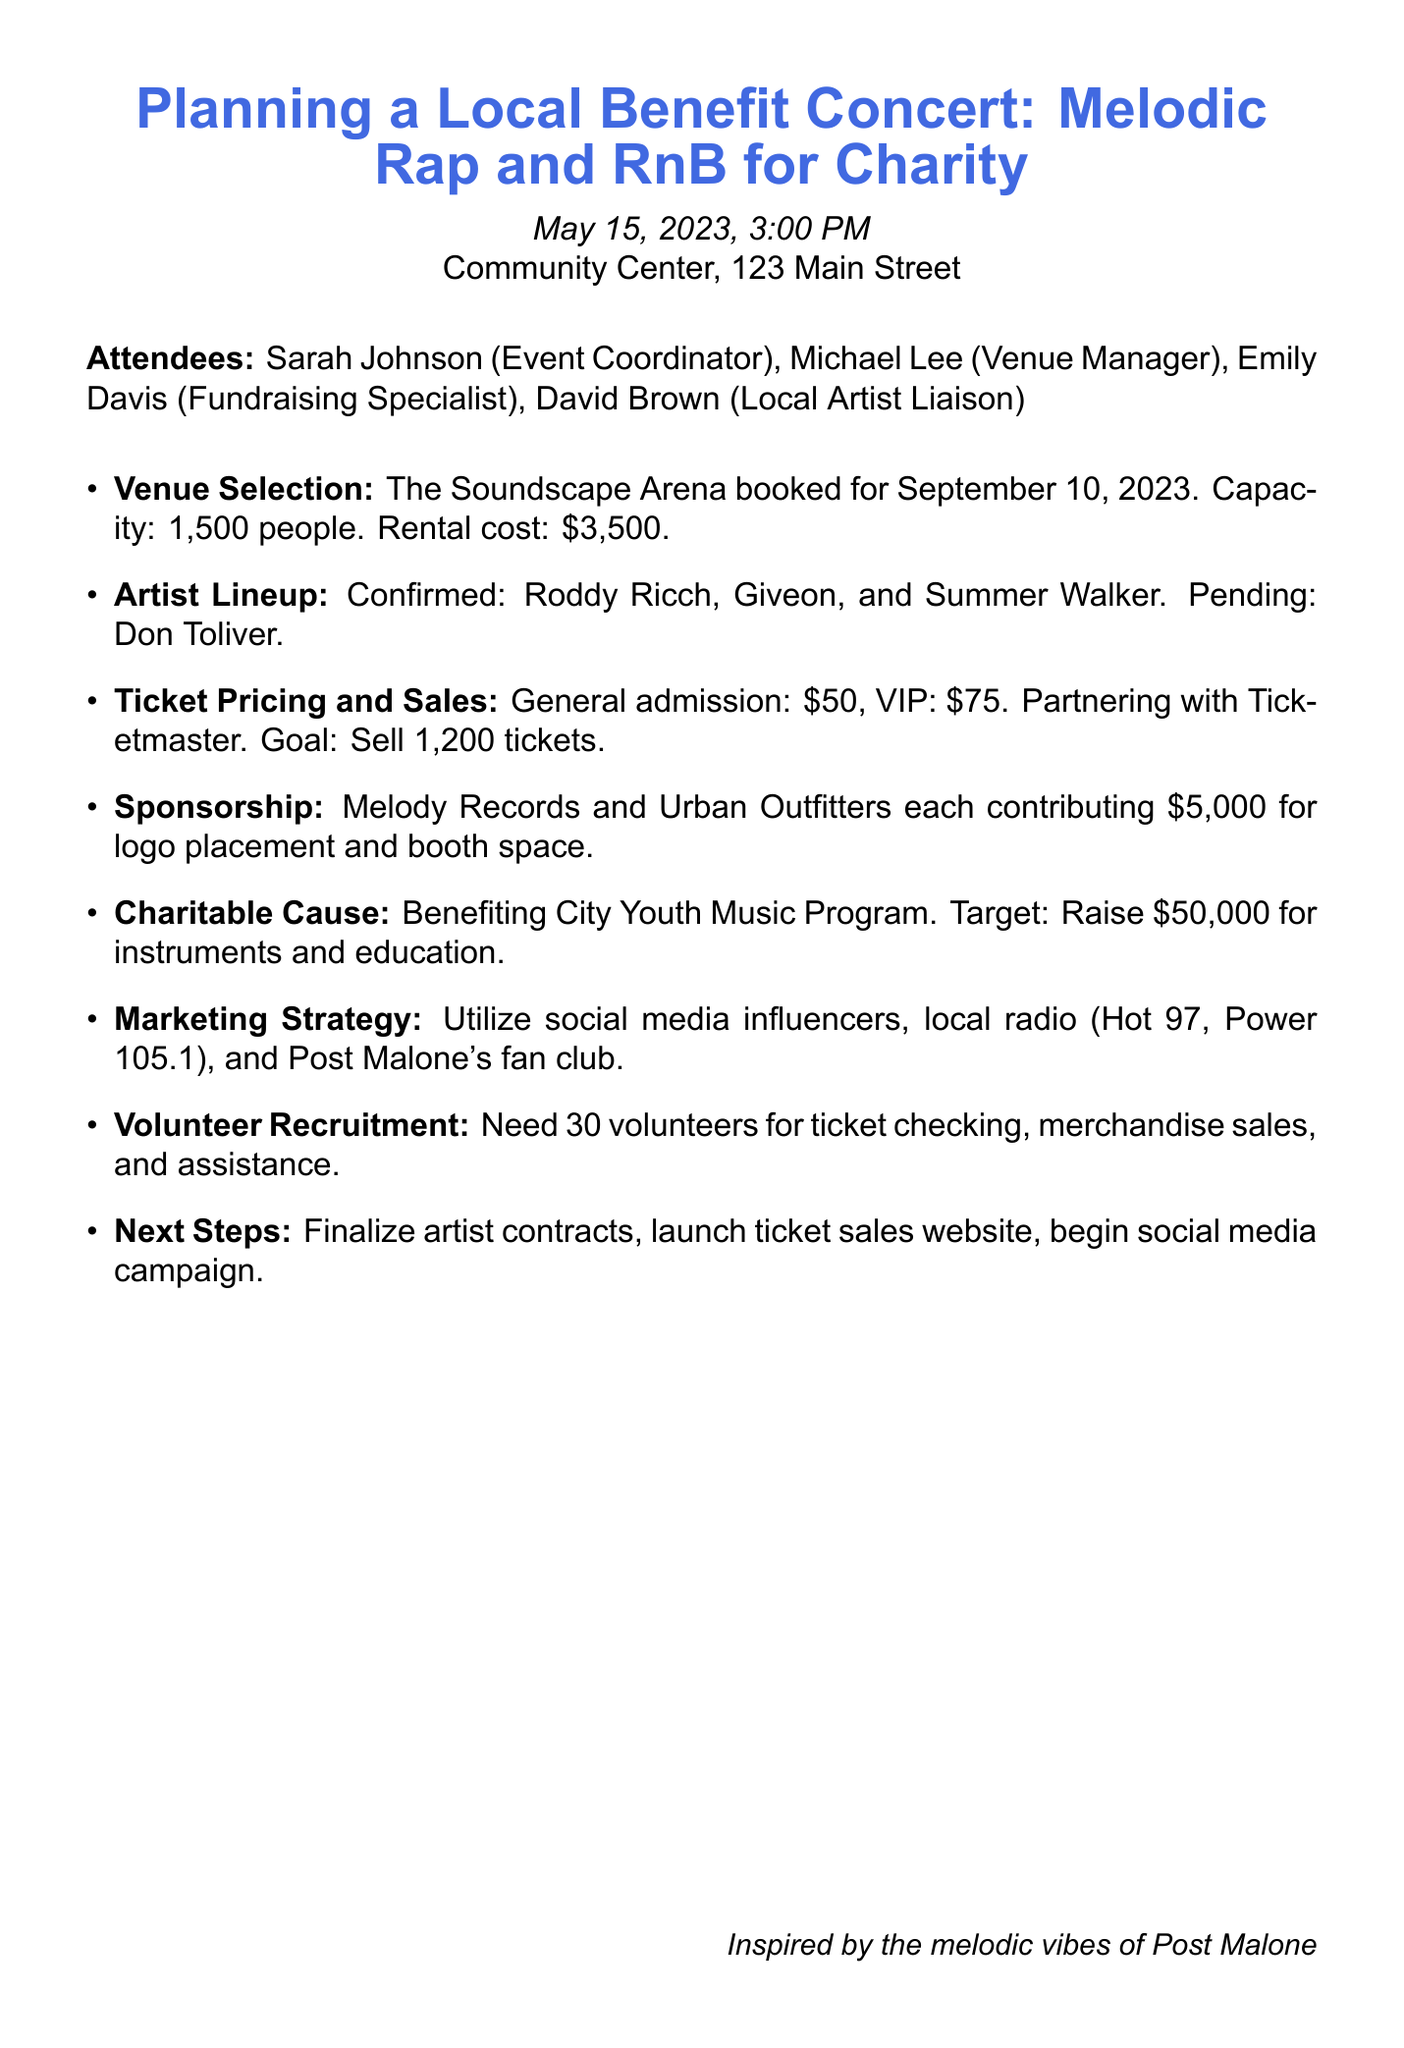What is the date of the concert? The concert is scheduled for September 10, 2023, as mentioned in the agenda under Venue Selection.
Answer: September 10, 2023 Who is the Event Coordinator? Sarah Johnson is listed as the Event Coordinator in the attendees section of the document.
Answer: Sarah Johnson What is the capacity of The Soundscape Arena? The capacity of The Soundscape Arena is mentioned to be 1,500 people under Venue Selection.
Answer: 1,500 people How much do VIP tickets cost? The cost of VIP tickets is specified as $75 in the Ticket Pricing and Sales section.
Answer: $75 Which artists are confirmed for the concert? The confirmed artists include Roddy Ricch, Giveon, and Summer Walker, stated in the Artist Lineup section of the document.
Answer: Roddy Ricch, Giveon, Summer Walker What is the fundraising target for the charity? The target to raise is outlined in the Charitable Cause section, stating a goal of $50,000.
Answer: $50,000 Which local radio stations are included in the marketing strategy? The document mentions Hot 97 and Power 105.1 as local radio stations in the Marketing Strategy section.
Answer: Hot 97, Power 105.1 How many volunteers are needed for the event? The Volunteer Recruitment section indicates the need for 30 volunteers.
Answer: 30 volunteers What will the proceeds benefit? The proceeds are stated to benefit the City Youth Music Program in the Charitable Cause section.
Answer: City Youth Music Program 